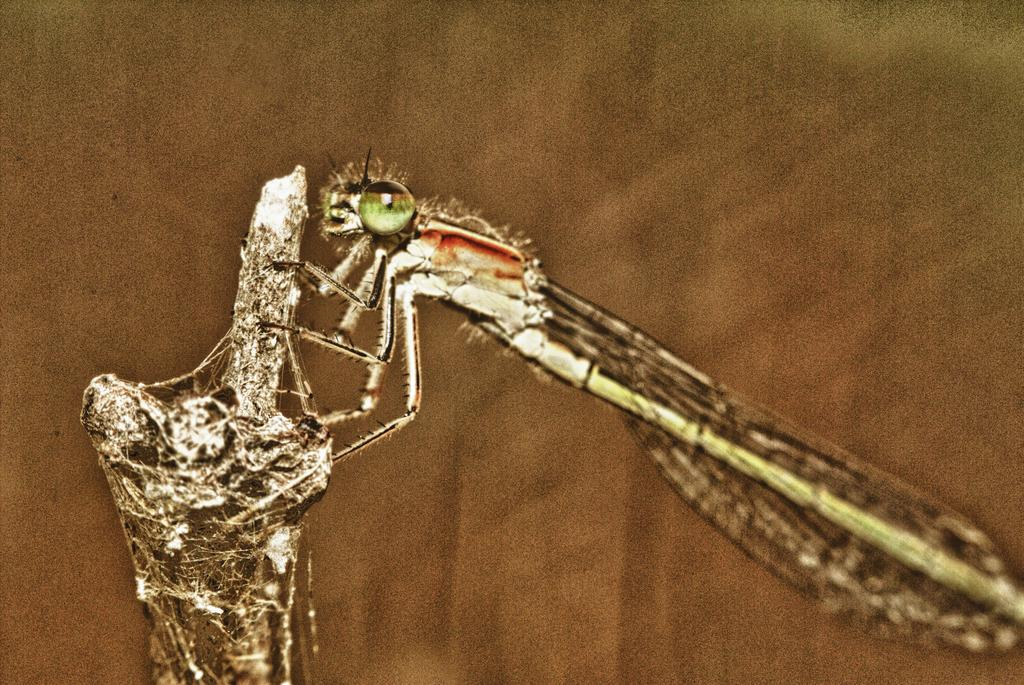What is present on the stem of the tree in the image? There is a fly on the stem of a tree in the image. What can be observed about the background of the image? The background appears to be brown in color, and it is blurred. How many donkeys can be seen on the island in the image? There is no island or donkey present in the image; it features a fly on the stem of a tree with a brown, blurred background. 